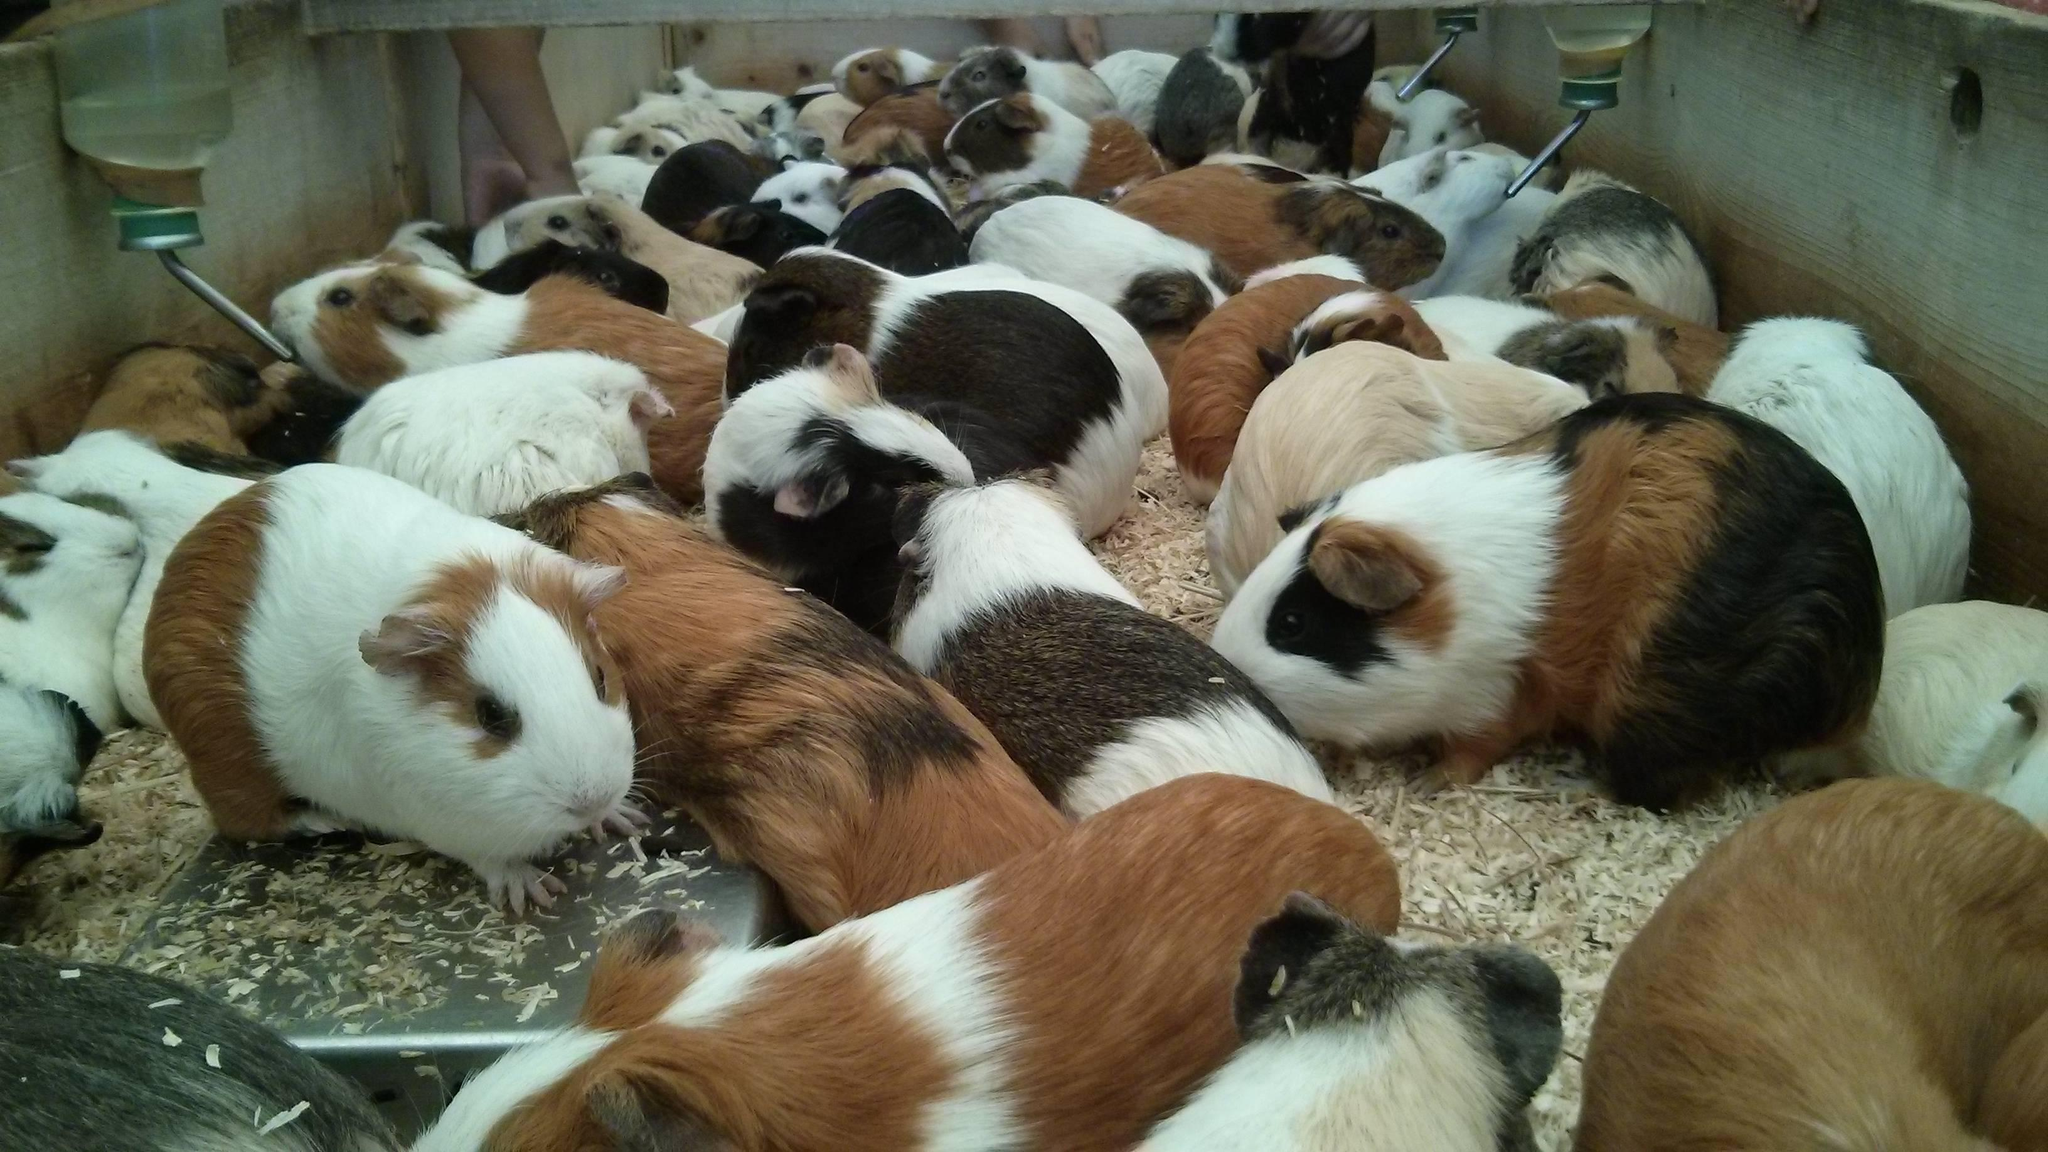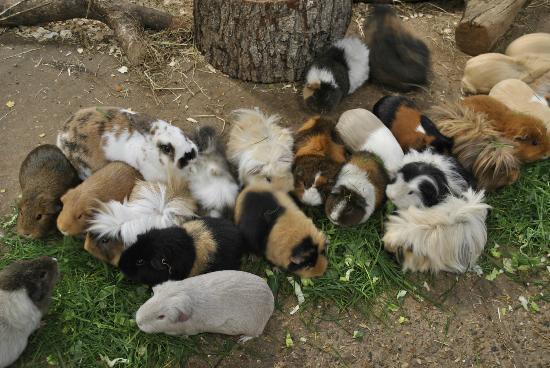The first image is the image on the left, the second image is the image on the right. For the images displayed, is the sentence "At least one of the pictures shows less than 10 rodents." factually correct? Answer yes or no. No. The first image is the image on the left, the second image is the image on the right. Analyze the images presented: Is the assertion "Left image contains no more than five hamsters, which are in a wood-sided enclosure." valid? Answer yes or no. No. 